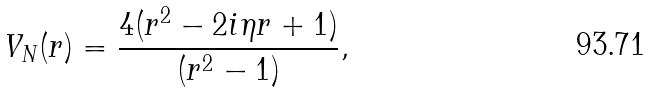Convert formula to latex. <formula><loc_0><loc_0><loc_500><loc_500>V _ { N } ( r ) = \frac { 4 ( r ^ { 2 } - 2 i \eta r + 1 ) } { ( r ^ { 2 } - 1 ) } ,</formula> 